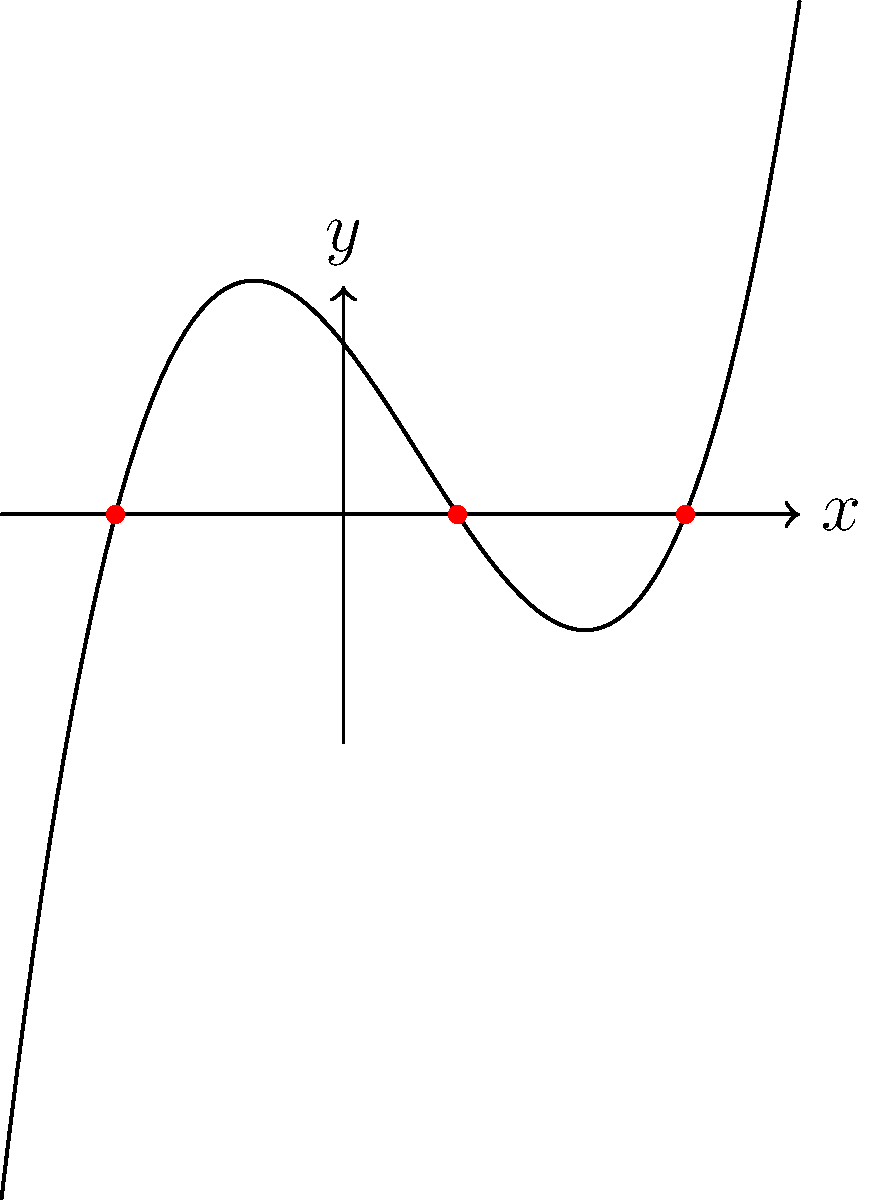As a parent who values quality education, you understand the importance of mathematical skills in problem-solving. Consider the graph of a polynomial function shown above. What are the roots of this polynomial function? Express your answer as a set of x-coordinates. To find the roots of a polynomial function from its graph, we need to identify the x-intercepts, which are the points where the graph crosses the x-axis. These points represent the solutions to the equation $f(x) = 0$.

Step 1: Observe the graph and locate all points where it intersects the x-axis.

Step 2: Identify the x-coordinates of these intersection points:
- The first root is at $x = -2$
- The second root is at $x = 1$
- The third root is at $x = 3$

Step 3: Express these roots as a set of x-coordinates.

This problem demonstrates the importance of graphical interpretation in mathematics, a skill that is crucial for students to develop in our schools.
Answer: $\{-2, 1, 3\}$ 